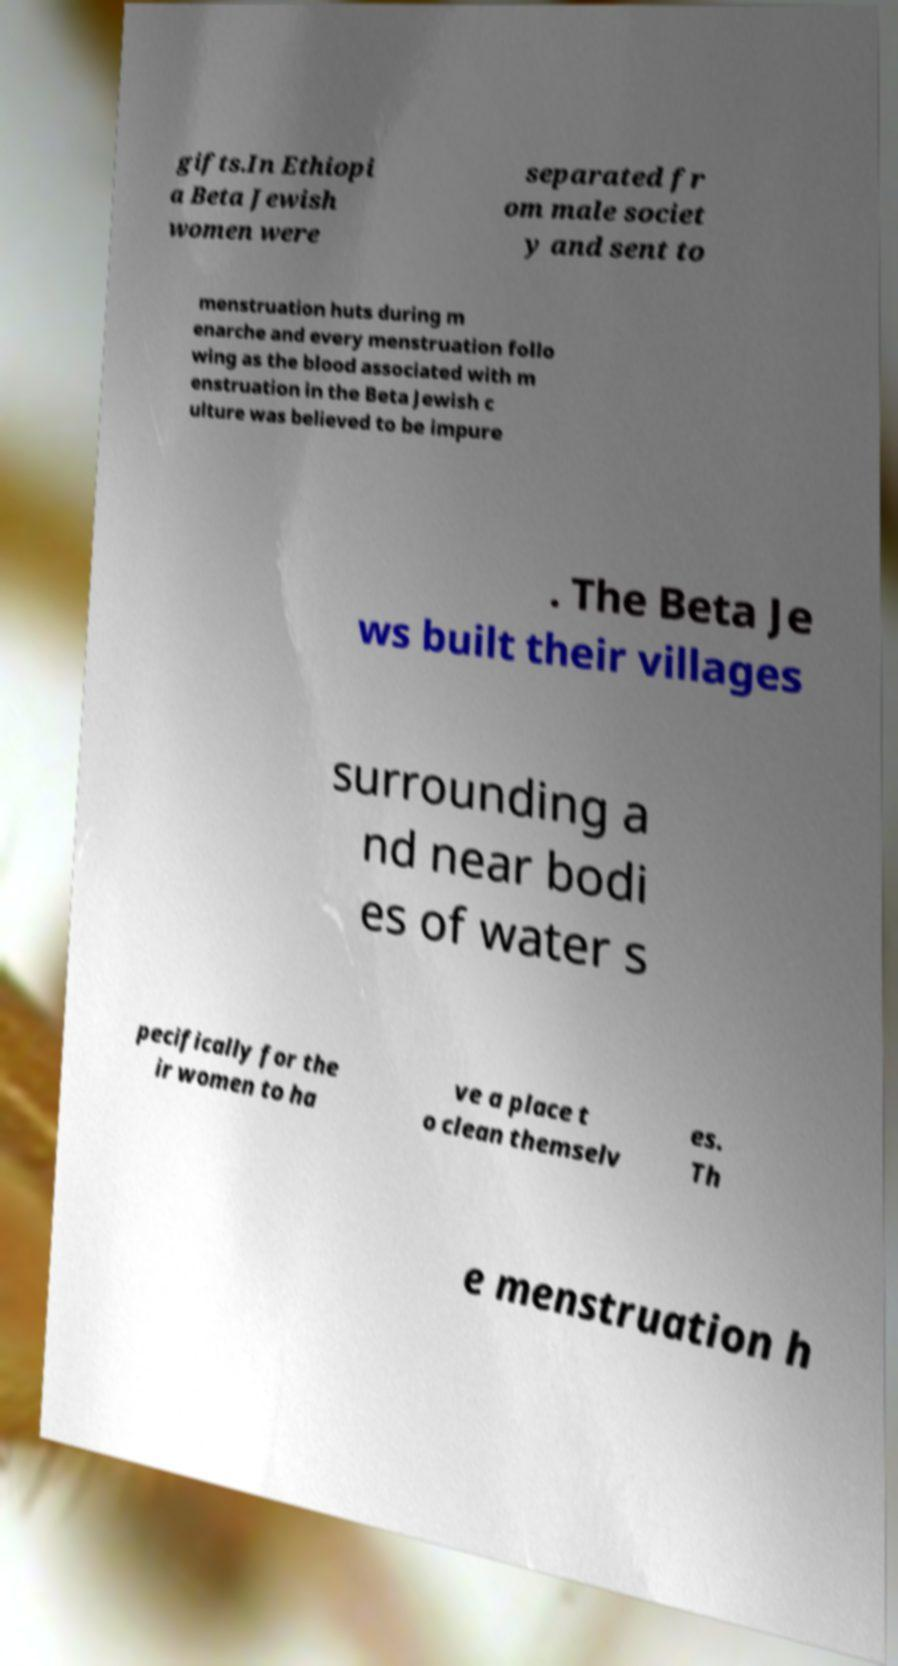Could you extract and type out the text from this image? gifts.In Ethiopi a Beta Jewish women were separated fr om male societ y and sent to menstruation huts during m enarche and every menstruation follo wing as the blood associated with m enstruation in the Beta Jewish c ulture was believed to be impure . The Beta Je ws built their villages surrounding a nd near bodi es of water s pecifically for the ir women to ha ve a place t o clean themselv es. Th e menstruation h 